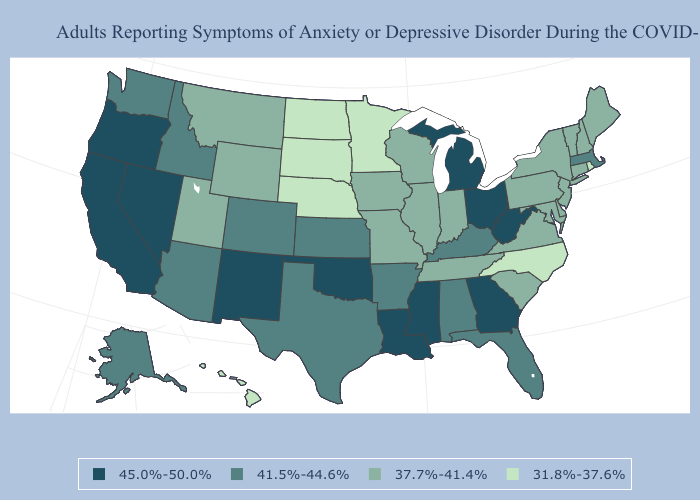Which states have the lowest value in the South?
Write a very short answer. North Carolina. Name the states that have a value in the range 41.5%-44.6%?
Keep it brief. Alabama, Alaska, Arizona, Arkansas, Colorado, Florida, Idaho, Kansas, Kentucky, Massachusetts, Texas, Washington. Among the states that border Rhode Island , does Massachusetts have the lowest value?
Be succinct. No. Which states have the highest value in the USA?
Give a very brief answer. California, Georgia, Louisiana, Michigan, Mississippi, Nevada, New Mexico, Ohio, Oklahoma, Oregon, West Virginia. Does the map have missing data?
Give a very brief answer. No. Does Massachusetts have the highest value in the Northeast?
Write a very short answer. Yes. Does the map have missing data?
Be succinct. No. What is the value of Louisiana?
Concise answer only. 45.0%-50.0%. What is the value of North Dakota?
Short answer required. 31.8%-37.6%. Does Rhode Island have a higher value than Vermont?
Write a very short answer. No. Among the states that border Kentucky , does Indiana have the highest value?
Give a very brief answer. No. Does Hawaii have the lowest value in the West?
Answer briefly. Yes. What is the lowest value in the USA?
Give a very brief answer. 31.8%-37.6%. What is the value of Alaska?
Quick response, please. 41.5%-44.6%. How many symbols are there in the legend?
Quick response, please. 4. 